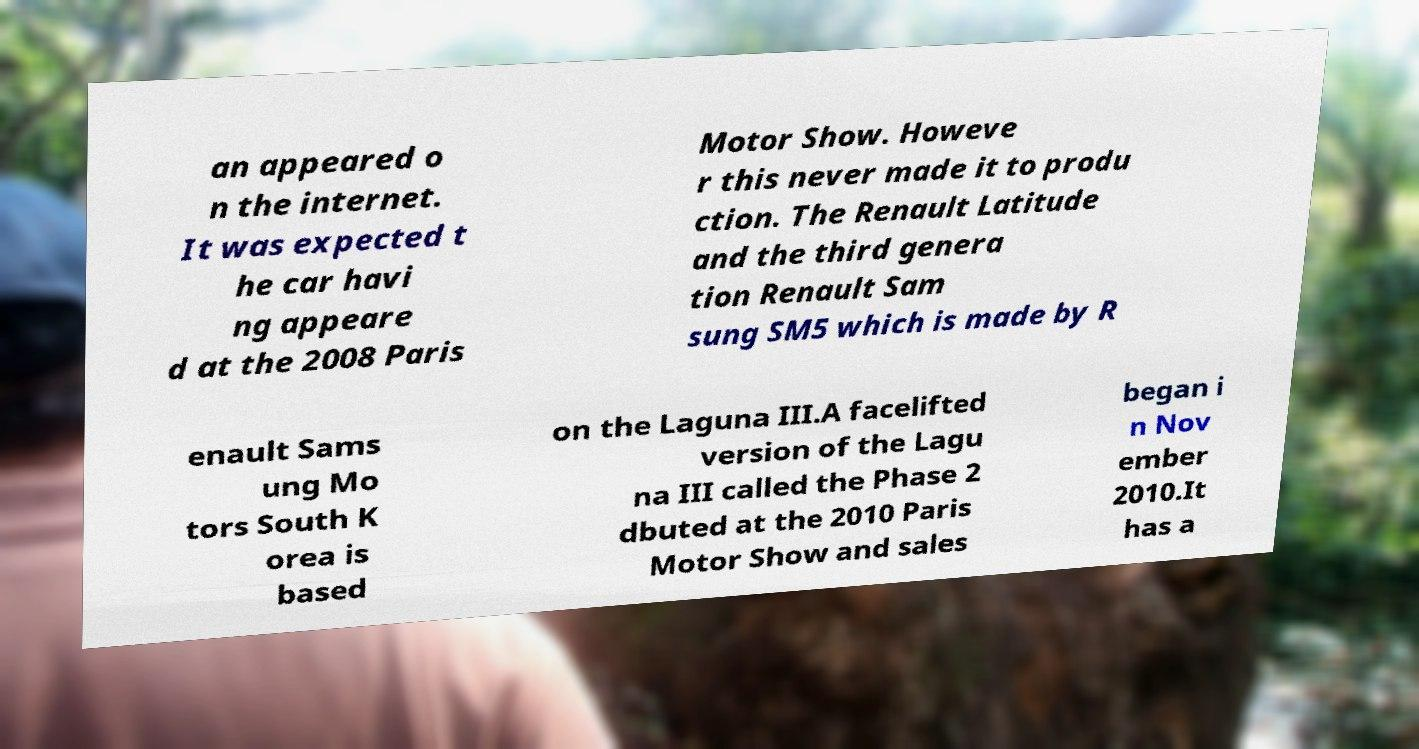Please identify and transcribe the text found in this image. an appeared o n the internet. It was expected t he car havi ng appeare d at the 2008 Paris Motor Show. Howeve r this never made it to produ ction. The Renault Latitude and the third genera tion Renault Sam sung SM5 which is made by R enault Sams ung Mo tors South K orea is based on the Laguna III.A facelifted version of the Lagu na III called the Phase 2 dbuted at the 2010 Paris Motor Show and sales began i n Nov ember 2010.It has a 